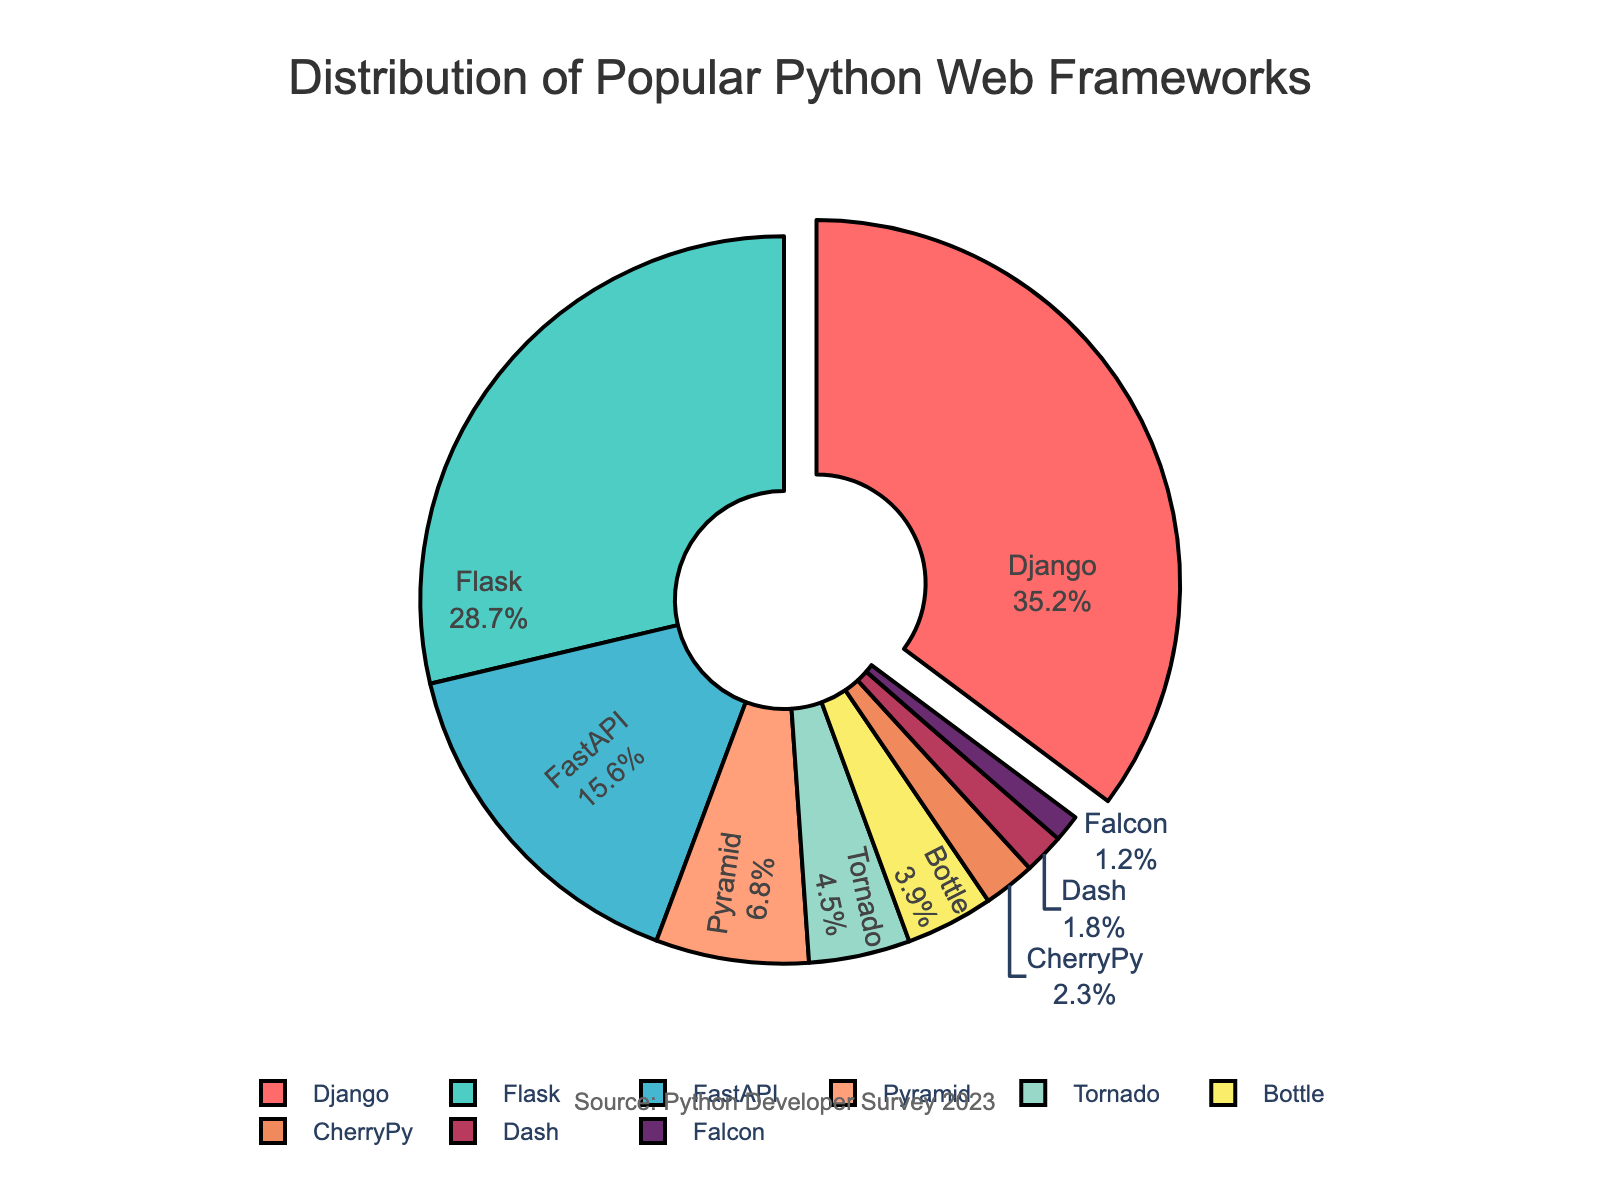Which framework has the largest share? The largest share can be identified by looking for the biggest segment in the pie chart, which is highlighted with a slight pull-out effect. This segment is labeled 'Django' with a percentage of 35.2%.
Answer: Django Which two frameworks have the lowest percentage of usage, and what are their combined percentages? The smallest segments in the pie chart are 'Falcon' at 1.2% and 'Dash' at 1.8%. Adding these percentages together: 1.2% + 1.8% = 3.0%.
Answer: Falcon and Dash, 3.0% How much larger in percentage is Django's share compared to Flask's share? To determine the difference in their shares, subtract Flask's percentage from Django's percentage: 35.2% - 28.7% = 6.5%.
Answer: 6.5% What is the combined percentage of the top three frameworks? The top three frameworks are identified as Django, Flask, and FastAPI by their segment sizes. Adding their percentages together: 35.2% + 28.7% + 15.6% = 79.5%.
Answer: 79.5% How does the share of Pyramid compare to the combined share of Tornado and Bottle? Pyramid has a share of 6.8%, and the combined share of Tornado and Bottle is 4.5% + 3.9% = 8.4%. Comparing these, Pyramid's 6.8% is less than Tornado and Bottle's combined 8.4%.
Answer: Less What visual element distinguishes the framework with the largest share from the others? Django is distinguished by a pull-out effect from the rest of the pie, making it stand out visually.
Answer: Pull-out effect What is the percentage difference between the shares of Bottle and CherryPy? Subtracting the percentage of CherryPy from that of Bottle: 3.9% - 2.3% = 1.6%.
Answer: 1.6% Which framework has a share closest to 5%, and what is its exact percentage? Pyramid has a percentage of 6.8%, which is closest to 5% compared to other segments.
Answer: Pyramid, 6.8% Is there a framework with exactly half the share of FastAPI? If so, which one? FastAPI has a share of 15.6%, half of which is 7.8%. No other framework has a share close to 7.8%.
Answer: No 